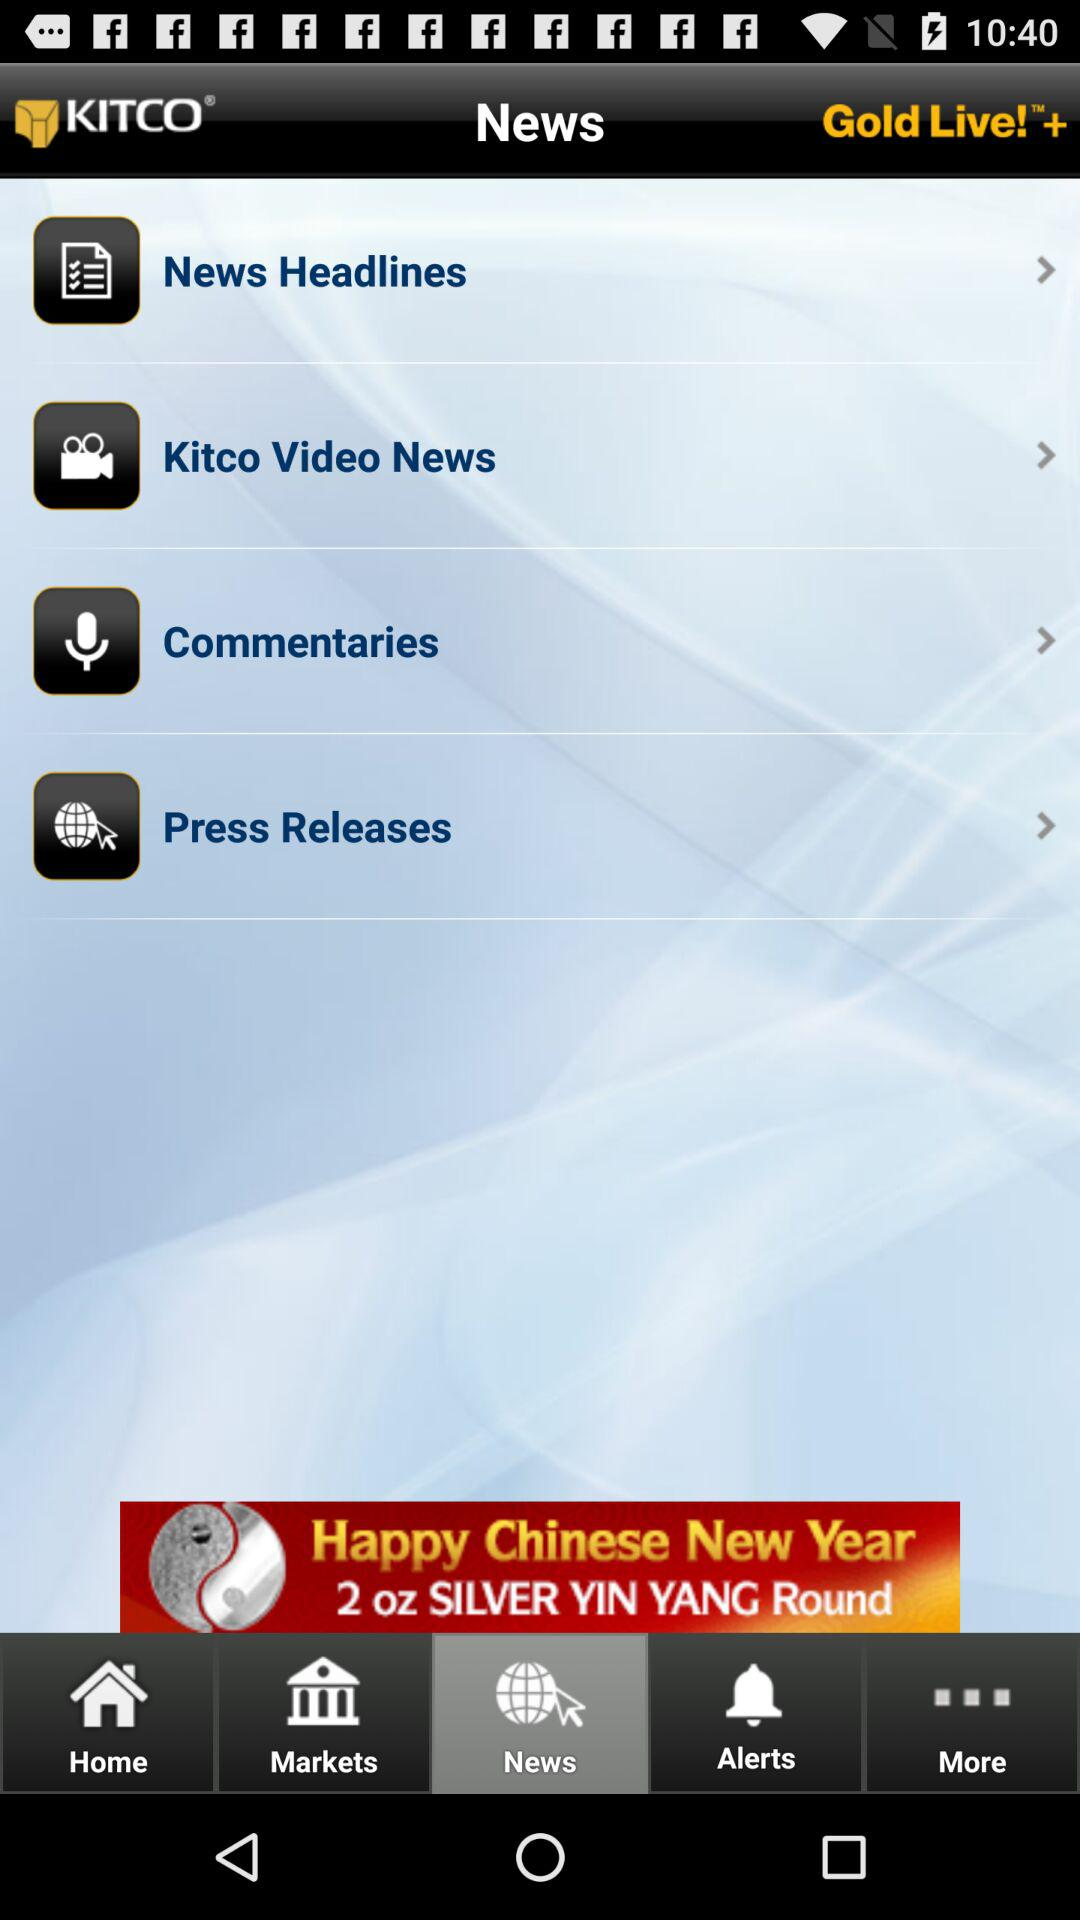What is the application name? The application name is "Gold Live!™+". 